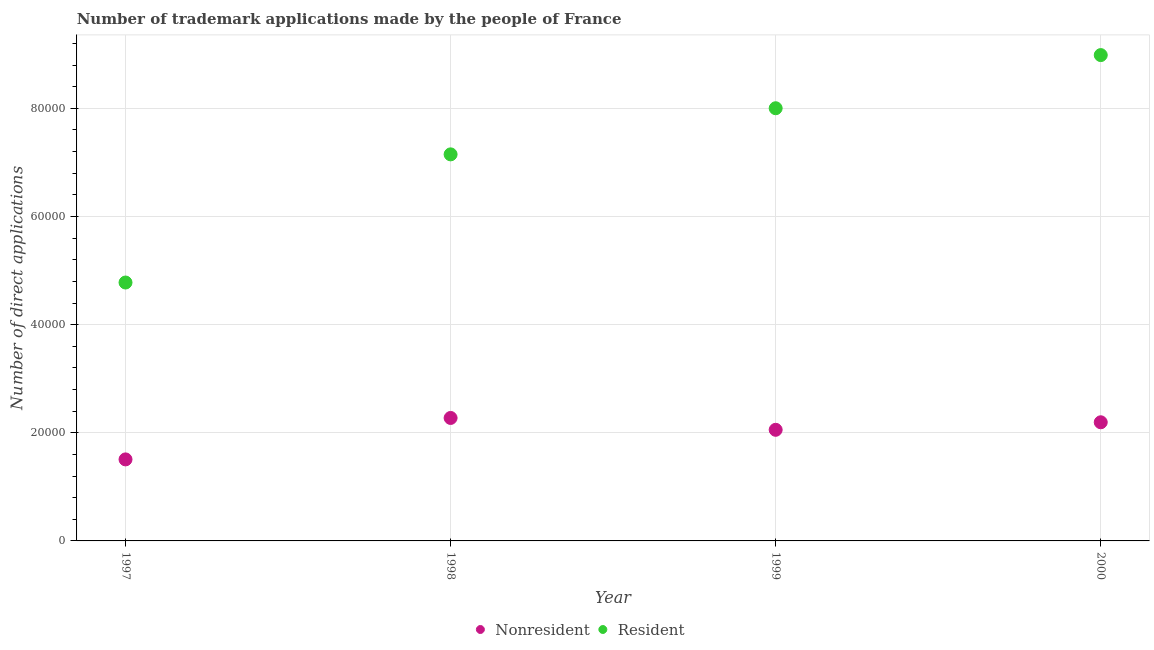Is the number of dotlines equal to the number of legend labels?
Your response must be concise. Yes. What is the number of trademark applications made by residents in 1999?
Your answer should be compact. 8.00e+04. Across all years, what is the maximum number of trademark applications made by residents?
Your answer should be compact. 8.98e+04. Across all years, what is the minimum number of trademark applications made by residents?
Your response must be concise. 4.78e+04. In which year was the number of trademark applications made by non residents maximum?
Ensure brevity in your answer.  1998. In which year was the number of trademark applications made by residents minimum?
Your answer should be very brief. 1997. What is the total number of trademark applications made by non residents in the graph?
Provide a short and direct response. 8.03e+04. What is the difference between the number of trademark applications made by residents in 1997 and that in 2000?
Make the answer very short. -4.21e+04. What is the difference between the number of trademark applications made by non residents in 1999 and the number of trademark applications made by residents in 2000?
Provide a short and direct response. -6.93e+04. What is the average number of trademark applications made by non residents per year?
Ensure brevity in your answer.  2.01e+04. In the year 1997, what is the difference between the number of trademark applications made by non residents and number of trademark applications made by residents?
Provide a short and direct response. -3.27e+04. In how many years, is the number of trademark applications made by non residents greater than 68000?
Your answer should be very brief. 0. What is the ratio of the number of trademark applications made by non residents in 1997 to that in 1999?
Provide a succinct answer. 0.73. Is the number of trademark applications made by residents in 1998 less than that in 1999?
Offer a very short reply. Yes. Is the difference between the number of trademark applications made by residents in 1997 and 2000 greater than the difference between the number of trademark applications made by non residents in 1997 and 2000?
Your response must be concise. No. What is the difference between the highest and the second highest number of trademark applications made by non residents?
Make the answer very short. 799. What is the difference between the highest and the lowest number of trademark applications made by residents?
Keep it short and to the point. 4.21e+04. Is the sum of the number of trademark applications made by residents in 1997 and 1999 greater than the maximum number of trademark applications made by non residents across all years?
Your response must be concise. Yes. Does the number of trademark applications made by non residents monotonically increase over the years?
Provide a succinct answer. No. Is the number of trademark applications made by non residents strictly less than the number of trademark applications made by residents over the years?
Offer a terse response. Yes. How many years are there in the graph?
Make the answer very short. 4. What is the difference between two consecutive major ticks on the Y-axis?
Offer a very short reply. 2.00e+04. Are the values on the major ticks of Y-axis written in scientific E-notation?
Your answer should be very brief. No. Does the graph contain any zero values?
Offer a very short reply. No. Does the graph contain grids?
Offer a very short reply. Yes. Where does the legend appear in the graph?
Your answer should be compact. Bottom center. How many legend labels are there?
Keep it short and to the point. 2. How are the legend labels stacked?
Your answer should be very brief. Horizontal. What is the title of the graph?
Make the answer very short. Number of trademark applications made by the people of France. Does "By country of asylum" appear as one of the legend labels in the graph?
Make the answer very short. No. What is the label or title of the Y-axis?
Give a very brief answer. Number of direct applications. What is the Number of direct applications of Nonresident in 1997?
Keep it short and to the point. 1.51e+04. What is the Number of direct applications of Resident in 1997?
Your answer should be very brief. 4.78e+04. What is the Number of direct applications in Nonresident in 1998?
Give a very brief answer. 2.27e+04. What is the Number of direct applications in Resident in 1998?
Ensure brevity in your answer.  7.15e+04. What is the Number of direct applications in Nonresident in 1999?
Make the answer very short. 2.06e+04. What is the Number of direct applications in Resident in 1999?
Offer a very short reply. 8.00e+04. What is the Number of direct applications in Nonresident in 2000?
Your response must be concise. 2.19e+04. What is the Number of direct applications of Resident in 2000?
Your response must be concise. 8.98e+04. Across all years, what is the maximum Number of direct applications of Nonresident?
Provide a short and direct response. 2.27e+04. Across all years, what is the maximum Number of direct applications in Resident?
Your answer should be compact. 8.98e+04. Across all years, what is the minimum Number of direct applications in Nonresident?
Provide a short and direct response. 1.51e+04. Across all years, what is the minimum Number of direct applications of Resident?
Offer a very short reply. 4.78e+04. What is the total Number of direct applications in Nonresident in the graph?
Give a very brief answer. 8.03e+04. What is the total Number of direct applications in Resident in the graph?
Offer a terse response. 2.89e+05. What is the difference between the Number of direct applications of Nonresident in 1997 and that in 1998?
Offer a very short reply. -7664. What is the difference between the Number of direct applications of Resident in 1997 and that in 1998?
Provide a succinct answer. -2.37e+04. What is the difference between the Number of direct applications of Nonresident in 1997 and that in 1999?
Ensure brevity in your answer.  -5473. What is the difference between the Number of direct applications in Resident in 1997 and that in 1999?
Offer a very short reply. -3.22e+04. What is the difference between the Number of direct applications of Nonresident in 1997 and that in 2000?
Give a very brief answer. -6865. What is the difference between the Number of direct applications of Resident in 1997 and that in 2000?
Offer a terse response. -4.21e+04. What is the difference between the Number of direct applications in Nonresident in 1998 and that in 1999?
Make the answer very short. 2191. What is the difference between the Number of direct applications of Resident in 1998 and that in 1999?
Your answer should be compact. -8529. What is the difference between the Number of direct applications of Nonresident in 1998 and that in 2000?
Provide a short and direct response. 799. What is the difference between the Number of direct applications in Resident in 1998 and that in 2000?
Give a very brief answer. -1.84e+04. What is the difference between the Number of direct applications of Nonresident in 1999 and that in 2000?
Provide a succinct answer. -1392. What is the difference between the Number of direct applications in Resident in 1999 and that in 2000?
Your answer should be compact. -9830. What is the difference between the Number of direct applications in Nonresident in 1997 and the Number of direct applications in Resident in 1998?
Provide a short and direct response. -5.64e+04. What is the difference between the Number of direct applications in Nonresident in 1997 and the Number of direct applications in Resident in 1999?
Your answer should be compact. -6.49e+04. What is the difference between the Number of direct applications in Nonresident in 1997 and the Number of direct applications in Resident in 2000?
Offer a very short reply. -7.48e+04. What is the difference between the Number of direct applications in Nonresident in 1998 and the Number of direct applications in Resident in 1999?
Your answer should be very brief. -5.73e+04. What is the difference between the Number of direct applications in Nonresident in 1998 and the Number of direct applications in Resident in 2000?
Your answer should be compact. -6.71e+04. What is the difference between the Number of direct applications in Nonresident in 1999 and the Number of direct applications in Resident in 2000?
Your answer should be very brief. -6.93e+04. What is the average Number of direct applications of Nonresident per year?
Your answer should be compact. 2.01e+04. What is the average Number of direct applications of Resident per year?
Provide a succinct answer. 7.23e+04. In the year 1997, what is the difference between the Number of direct applications of Nonresident and Number of direct applications of Resident?
Your response must be concise. -3.27e+04. In the year 1998, what is the difference between the Number of direct applications in Nonresident and Number of direct applications in Resident?
Provide a succinct answer. -4.88e+04. In the year 1999, what is the difference between the Number of direct applications in Nonresident and Number of direct applications in Resident?
Offer a terse response. -5.95e+04. In the year 2000, what is the difference between the Number of direct applications in Nonresident and Number of direct applications in Resident?
Your answer should be very brief. -6.79e+04. What is the ratio of the Number of direct applications in Nonresident in 1997 to that in 1998?
Make the answer very short. 0.66. What is the ratio of the Number of direct applications in Resident in 1997 to that in 1998?
Offer a very short reply. 0.67. What is the ratio of the Number of direct applications of Nonresident in 1997 to that in 1999?
Give a very brief answer. 0.73. What is the ratio of the Number of direct applications of Resident in 1997 to that in 1999?
Provide a short and direct response. 0.6. What is the ratio of the Number of direct applications of Nonresident in 1997 to that in 2000?
Make the answer very short. 0.69. What is the ratio of the Number of direct applications in Resident in 1997 to that in 2000?
Your answer should be very brief. 0.53. What is the ratio of the Number of direct applications in Nonresident in 1998 to that in 1999?
Your response must be concise. 1.11. What is the ratio of the Number of direct applications of Resident in 1998 to that in 1999?
Provide a succinct answer. 0.89. What is the ratio of the Number of direct applications in Nonresident in 1998 to that in 2000?
Your answer should be very brief. 1.04. What is the ratio of the Number of direct applications of Resident in 1998 to that in 2000?
Ensure brevity in your answer.  0.8. What is the ratio of the Number of direct applications of Nonresident in 1999 to that in 2000?
Provide a succinct answer. 0.94. What is the ratio of the Number of direct applications in Resident in 1999 to that in 2000?
Your response must be concise. 0.89. What is the difference between the highest and the second highest Number of direct applications of Nonresident?
Ensure brevity in your answer.  799. What is the difference between the highest and the second highest Number of direct applications of Resident?
Ensure brevity in your answer.  9830. What is the difference between the highest and the lowest Number of direct applications in Nonresident?
Offer a terse response. 7664. What is the difference between the highest and the lowest Number of direct applications in Resident?
Give a very brief answer. 4.21e+04. 